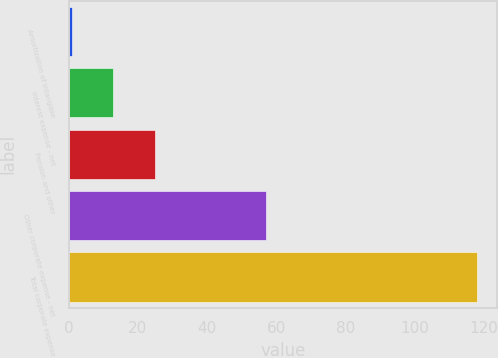<chart> <loc_0><loc_0><loc_500><loc_500><bar_chart><fcel>Amortization of intangible<fcel>Interest expense - net<fcel>Pension and other<fcel>Other corporate expense - net<fcel>Total corporate expense<nl><fcel>1<fcel>12.7<fcel>25<fcel>57<fcel>118<nl></chart> 